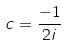Convert formula to latex. <formula><loc_0><loc_0><loc_500><loc_500>c = \frac { - 1 } { 2 i }</formula> 